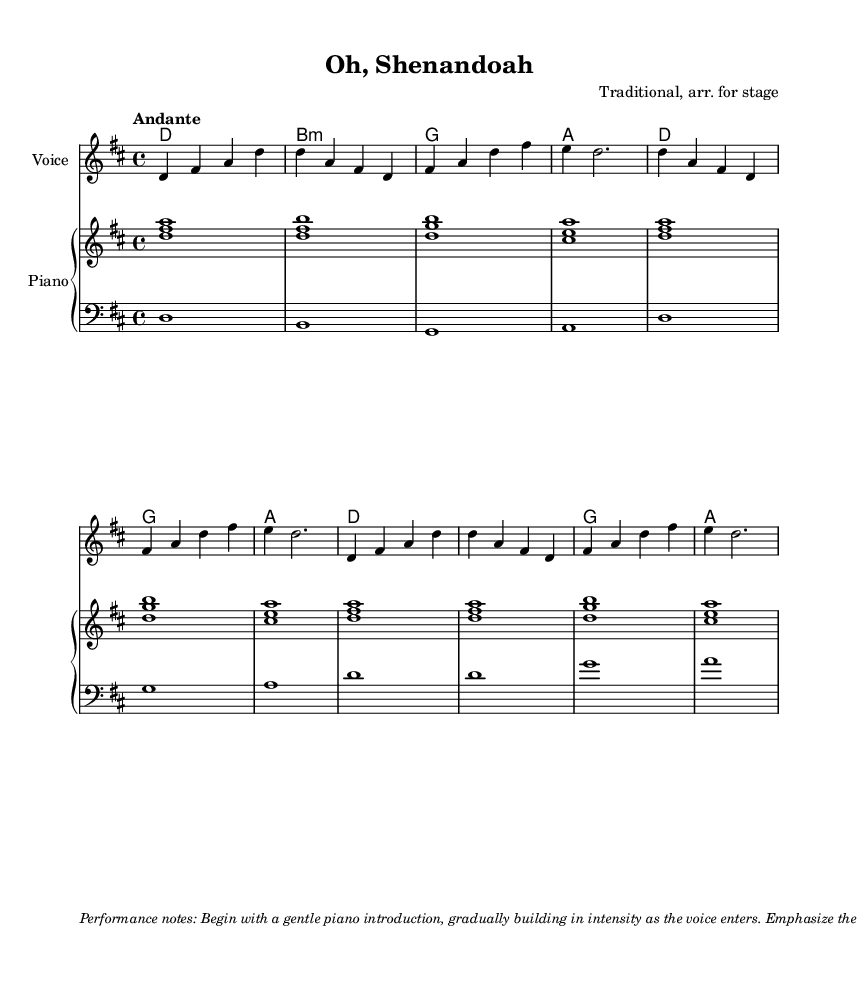What is the key signature of this music? The key signature shows two sharps, indicating that the piece is in D major. This can be identified by looking at the key signature at the beginning of the score.
Answer: D major What is the time signature of this music? The time signature shown at the beginning of the score is 4/4. This means there are four beats in each measure, and the quarter note gets one beat.
Answer: 4/4 What is the tempo marking for this piece? The tempo marking above the music states "Andante," which indicates a moderate walking pace. The choice of this term helps performers understand the intended speed.
Answer: Andante Name the traditional song that this arrangement is based on. The title at the top of the score is "Oh, Shenandoah," which is the name of the traditional American folk song being arranged.
Answer: Oh, Shenandoah How many measures are there in the melody section of the music? By counting the distinct sets of notes grouped by bars in the melody line, there are a total of eight measures in this section.
Answer: Eight What is the first chord of the piece? The first chord listed in the chord progression is D major, which is indicated by the notation in the harmonies section at the start of the score.
Answer: D What lyrical theme does the song convey? The lyrics express a longing for the river Shenandoah, conveying a sense of nostalgia and yearning which is central to folk music's emotional resonance.
Answer: Longing 